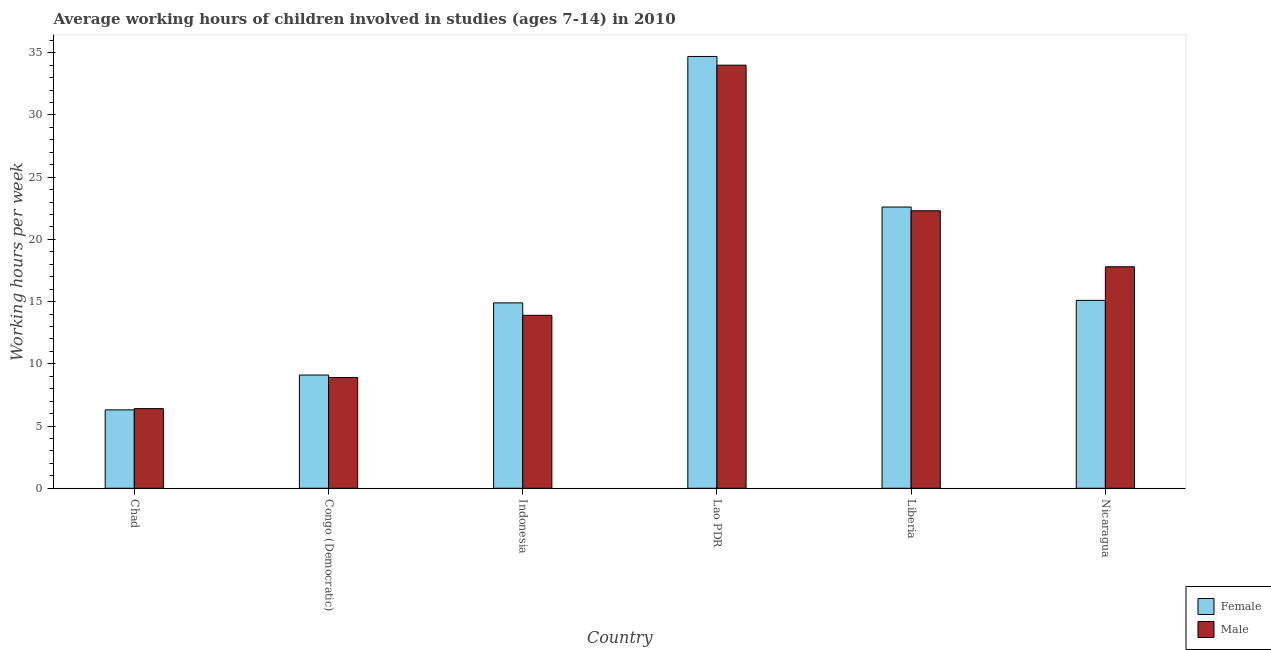How many different coloured bars are there?
Provide a succinct answer. 2. Are the number of bars per tick equal to the number of legend labels?
Give a very brief answer. Yes. How many bars are there on the 4th tick from the left?
Provide a succinct answer. 2. What is the label of the 3rd group of bars from the left?
Offer a very short reply. Indonesia. Across all countries, what is the maximum average working hour of female children?
Make the answer very short. 34.7. Across all countries, what is the minimum average working hour of female children?
Make the answer very short. 6.3. In which country was the average working hour of female children maximum?
Your answer should be very brief. Lao PDR. In which country was the average working hour of male children minimum?
Offer a terse response. Chad. What is the total average working hour of male children in the graph?
Your answer should be compact. 103.3. What is the average average working hour of male children per country?
Offer a terse response. 17.22. What is the difference between the average working hour of female children and average working hour of male children in Lao PDR?
Give a very brief answer. 0.7. In how many countries, is the average working hour of male children greater than 9 hours?
Your response must be concise. 4. What is the ratio of the average working hour of male children in Chad to that in Lao PDR?
Make the answer very short. 0.19. Is the average working hour of female children in Lao PDR less than that in Liberia?
Provide a short and direct response. No. What is the difference between the highest and the lowest average working hour of male children?
Offer a very short reply. 27.6. Is the sum of the average working hour of female children in Liberia and Nicaragua greater than the maximum average working hour of male children across all countries?
Make the answer very short. Yes. What does the 1st bar from the left in Liberia represents?
Ensure brevity in your answer.  Female. How many bars are there?
Give a very brief answer. 12. What is the difference between two consecutive major ticks on the Y-axis?
Provide a succinct answer. 5. Are the values on the major ticks of Y-axis written in scientific E-notation?
Make the answer very short. No. Does the graph contain any zero values?
Your response must be concise. No. Does the graph contain grids?
Your response must be concise. No. Where does the legend appear in the graph?
Your answer should be very brief. Bottom right. How many legend labels are there?
Provide a short and direct response. 2. How are the legend labels stacked?
Offer a terse response. Vertical. What is the title of the graph?
Your response must be concise. Average working hours of children involved in studies (ages 7-14) in 2010. What is the label or title of the Y-axis?
Your answer should be very brief. Working hours per week. What is the Working hours per week of Female in Congo (Democratic)?
Make the answer very short. 9.1. What is the Working hours per week of Male in Congo (Democratic)?
Offer a very short reply. 8.9. What is the Working hours per week in Female in Indonesia?
Your answer should be compact. 14.9. What is the Working hours per week of Female in Lao PDR?
Your answer should be compact. 34.7. What is the Working hours per week of Male in Lao PDR?
Make the answer very short. 34. What is the Working hours per week in Female in Liberia?
Your response must be concise. 22.6. What is the Working hours per week in Male in Liberia?
Your answer should be very brief. 22.3. What is the Working hours per week in Female in Nicaragua?
Provide a succinct answer. 15.1. Across all countries, what is the maximum Working hours per week in Female?
Keep it short and to the point. 34.7. Across all countries, what is the maximum Working hours per week in Male?
Make the answer very short. 34. Across all countries, what is the minimum Working hours per week of Female?
Your answer should be very brief. 6.3. Across all countries, what is the minimum Working hours per week in Male?
Offer a very short reply. 6.4. What is the total Working hours per week in Female in the graph?
Your answer should be compact. 102.7. What is the total Working hours per week in Male in the graph?
Provide a short and direct response. 103.3. What is the difference between the Working hours per week of Female in Chad and that in Congo (Democratic)?
Offer a very short reply. -2.8. What is the difference between the Working hours per week of Male in Chad and that in Congo (Democratic)?
Keep it short and to the point. -2.5. What is the difference between the Working hours per week of Female in Chad and that in Indonesia?
Offer a terse response. -8.6. What is the difference between the Working hours per week in Male in Chad and that in Indonesia?
Give a very brief answer. -7.5. What is the difference between the Working hours per week of Female in Chad and that in Lao PDR?
Provide a succinct answer. -28.4. What is the difference between the Working hours per week of Male in Chad and that in Lao PDR?
Offer a terse response. -27.6. What is the difference between the Working hours per week in Female in Chad and that in Liberia?
Give a very brief answer. -16.3. What is the difference between the Working hours per week in Male in Chad and that in Liberia?
Keep it short and to the point. -15.9. What is the difference between the Working hours per week of Female in Chad and that in Nicaragua?
Ensure brevity in your answer.  -8.8. What is the difference between the Working hours per week of Female in Congo (Democratic) and that in Indonesia?
Offer a very short reply. -5.8. What is the difference between the Working hours per week of Female in Congo (Democratic) and that in Lao PDR?
Ensure brevity in your answer.  -25.6. What is the difference between the Working hours per week in Male in Congo (Democratic) and that in Lao PDR?
Offer a very short reply. -25.1. What is the difference between the Working hours per week in Female in Congo (Democratic) and that in Liberia?
Ensure brevity in your answer.  -13.5. What is the difference between the Working hours per week of Male in Congo (Democratic) and that in Liberia?
Provide a succinct answer. -13.4. What is the difference between the Working hours per week in Female in Congo (Democratic) and that in Nicaragua?
Offer a terse response. -6. What is the difference between the Working hours per week in Male in Congo (Democratic) and that in Nicaragua?
Ensure brevity in your answer.  -8.9. What is the difference between the Working hours per week in Female in Indonesia and that in Lao PDR?
Give a very brief answer. -19.8. What is the difference between the Working hours per week of Male in Indonesia and that in Lao PDR?
Provide a succinct answer. -20.1. What is the difference between the Working hours per week of Female in Indonesia and that in Liberia?
Offer a very short reply. -7.7. What is the difference between the Working hours per week in Male in Indonesia and that in Liberia?
Make the answer very short. -8.4. What is the difference between the Working hours per week of Female in Indonesia and that in Nicaragua?
Provide a short and direct response. -0.2. What is the difference between the Working hours per week in Male in Indonesia and that in Nicaragua?
Keep it short and to the point. -3.9. What is the difference between the Working hours per week in Female in Lao PDR and that in Nicaragua?
Offer a terse response. 19.6. What is the difference between the Working hours per week of Male in Lao PDR and that in Nicaragua?
Keep it short and to the point. 16.2. What is the difference between the Working hours per week of Female in Chad and the Working hours per week of Male in Congo (Democratic)?
Give a very brief answer. -2.6. What is the difference between the Working hours per week of Female in Chad and the Working hours per week of Male in Lao PDR?
Your response must be concise. -27.7. What is the difference between the Working hours per week in Female in Chad and the Working hours per week in Male in Liberia?
Provide a succinct answer. -16. What is the difference between the Working hours per week in Female in Chad and the Working hours per week in Male in Nicaragua?
Your response must be concise. -11.5. What is the difference between the Working hours per week in Female in Congo (Democratic) and the Working hours per week in Male in Lao PDR?
Your answer should be very brief. -24.9. What is the difference between the Working hours per week in Female in Indonesia and the Working hours per week in Male in Lao PDR?
Provide a succinct answer. -19.1. What is the difference between the Working hours per week of Female in Indonesia and the Working hours per week of Male in Liberia?
Keep it short and to the point. -7.4. What is the difference between the Working hours per week in Female in Lao PDR and the Working hours per week in Male in Liberia?
Your answer should be very brief. 12.4. What is the difference between the Working hours per week in Female in Lao PDR and the Working hours per week in Male in Nicaragua?
Ensure brevity in your answer.  16.9. What is the difference between the Working hours per week in Female in Liberia and the Working hours per week in Male in Nicaragua?
Your answer should be compact. 4.8. What is the average Working hours per week in Female per country?
Your answer should be very brief. 17.12. What is the average Working hours per week in Male per country?
Offer a very short reply. 17.22. What is the difference between the Working hours per week in Female and Working hours per week in Male in Congo (Democratic)?
Offer a terse response. 0.2. What is the difference between the Working hours per week of Female and Working hours per week of Male in Lao PDR?
Your answer should be very brief. 0.7. What is the ratio of the Working hours per week in Female in Chad to that in Congo (Democratic)?
Your answer should be compact. 0.69. What is the ratio of the Working hours per week in Male in Chad to that in Congo (Democratic)?
Provide a short and direct response. 0.72. What is the ratio of the Working hours per week in Female in Chad to that in Indonesia?
Your response must be concise. 0.42. What is the ratio of the Working hours per week of Male in Chad to that in Indonesia?
Your response must be concise. 0.46. What is the ratio of the Working hours per week in Female in Chad to that in Lao PDR?
Give a very brief answer. 0.18. What is the ratio of the Working hours per week of Male in Chad to that in Lao PDR?
Make the answer very short. 0.19. What is the ratio of the Working hours per week of Female in Chad to that in Liberia?
Ensure brevity in your answer.  0.28. What is the ratio of the Working hours per week in Male in Chad to that in Liberia?
Your answer should be compact. 0.29. What is the ratio of the Working hours per week of Female in Chad to that in Nicaragua?
Offer a very short reply. 0.42. What is the ratio of the Working hours per week in Male in Chad to that in Nicaragua?
Give a very brief answer. 0.36. What is the ratio of the Working hours per week in Female in Congo (Democratic) to that in Indonesia?
Give a very brief answer. 0.61. What is the ratio of the Working hours per week of Male in Congo (Democratic) to that in Indonesia?
Offer a very short reply. 0.64. What is the ratio of the Working hours per week in Female in Congo (Democratic) to that in Lao PDR?
Your answer should be very brief. 0.26. What is the ratio of the Working hours per week in Male in Congo (Democratic) to that in Lao PDR?
Your response must be concise. 0.26. What is the ratio of the Working hours per week in Female in Congo (Democratic) to that in Liberia?
Your response must be concise. 0.4. What is the ratio of the Working hours per week of Male in Congo (Democratic) to that in Liberia?
Provide a succinct answer. 0.4. What is the ratio of the Working hours per week of Female in Congo (Democratic) to that in Nicaragua?
Your answer should be compact. 0.6. What is the ratio of the Working hours per week in Male in Congo (Democratic) to that in Nicaragua?
Provide a succinct answer. 0.5. What is the ratio of the Working hours per week of Female in Indonesia to that in Lao PDR?
Keep it short and to the point. 0.43. What is the ratio of the Working hours per week in Male in Indonesia to that in Lao PDR?
Your answer should be compact. 0.41. What is the ratio of the Working hours per week of Female in Indonesia to that in Liberia?
Your answer should be compact. 0.66. What is the ratio of the Working hours per week in Male in Indonesia to that in Liberia?
Provide a short and direct response. 0.62. What is the ratio of the Working hours per week of Male in Indonesia to that in Nicaragua?
Offer a very short reply. 0.78. What is the ratio of the Working hours per week of Female in Lao PDR to that in Liberia?
Offer a very short reply. 1.54. What is the ratio of the Working hours per week of Male in Lao PDR to that in Liberia?
Your response must be concise. 1.52. What is the ratio of the Working hours per week in Female in Lao PDR to that in Nicaragua?
Keep it short and to the point. 2.3. What is the ratio of the Working hours per week in Male in Lao PDR to that in Nicaragua?
Offer a very short reply. 1.91. What is the ratio of the Working hours per week in Female in Liberia to that in Nicaragua?
Your answer should be compact. 1.5. What is the ratio of the Working hours per week in Male in Liberia to that in Nicaragua?
Ensure brevity in your answer.  1.25. What is the difference between the highest and the second highest Working hours per week of Male?
Provide a succinct answer. 11.7. What is the difference between the highest and the lowest Working hours per week of Female?
Your answer should be compact. 28.4. What is the difference between the highest and the lowest Working hours per week of Male?
Offer a terse response. 27.6. 